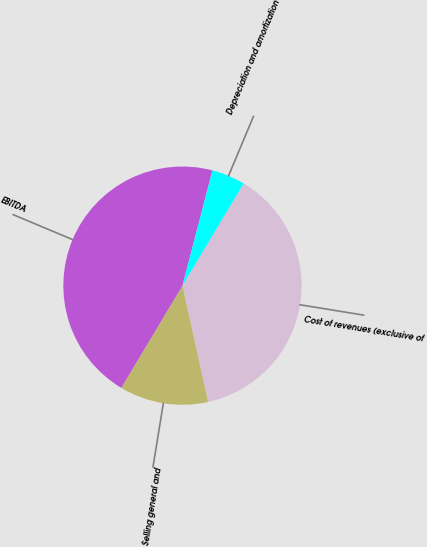Convert chart to OTSL. <chart><loc_0><loc_0><loc_500><loc_500><pie_chart><fcel>Cost of revenues (exclusive of<fcel>Selling general and<fcel>EBITDA<fcel>Depreciation and amortization<nl><fcel>37.96%<fcel>12.04%<fcel>45.48%<fcel>4.53%<nl></chart> 